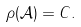Convert formula to latex. <formula><loc_0><loc_0><loc_500><loc_500>\rho ( \mathcal { A } ) = C .</formula> 